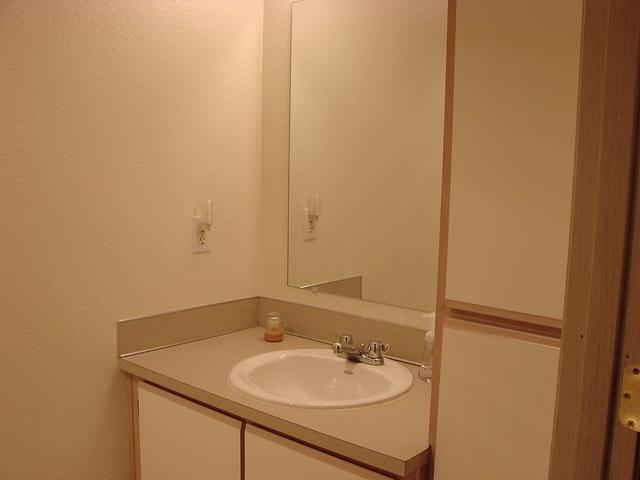Is there hand soap by the sink?
Quick response, please. Yes. What is the color of the sink?
Answer briefly. White. Does the bathroom appear to be occupied?
Write a very short answer. No. What type of countertops are shown in this photo?
Concise answer only. Laminate. 